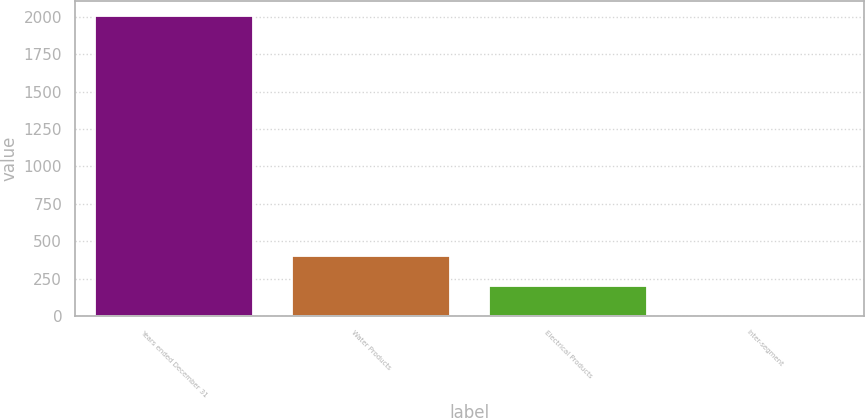Convert chart. <chart><loc_0><loc_0><loc_500><loc_500><bar_chart><fcel>Years ended December 31<fcel>Water Products<fcel>Electrical Products<fcel>Inter-segment<nl><fcel>2006<fcel>401.28<fcel>200.69<fcel>0.1<nl></chart> 